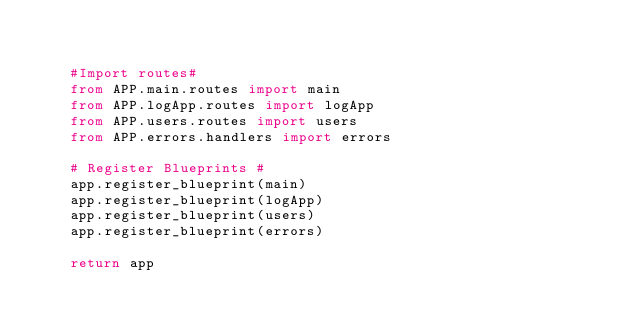Convert code to text. <code><loc_0><loc_0><loc_500><loc_500><_Python_>

    #Import routes#
    from APP.main.routes import main
    from APP.logApp.routes import logApp
    from APP.users.routes import users
    from APP.errors.handlers import errors

    # Register Blueprints #
    app.register_blueprint(main)
    app.register_blueprint(logApp)
    app.register_blueprint(users)
    app.register_blueprint(errors)

    return app




</code> 